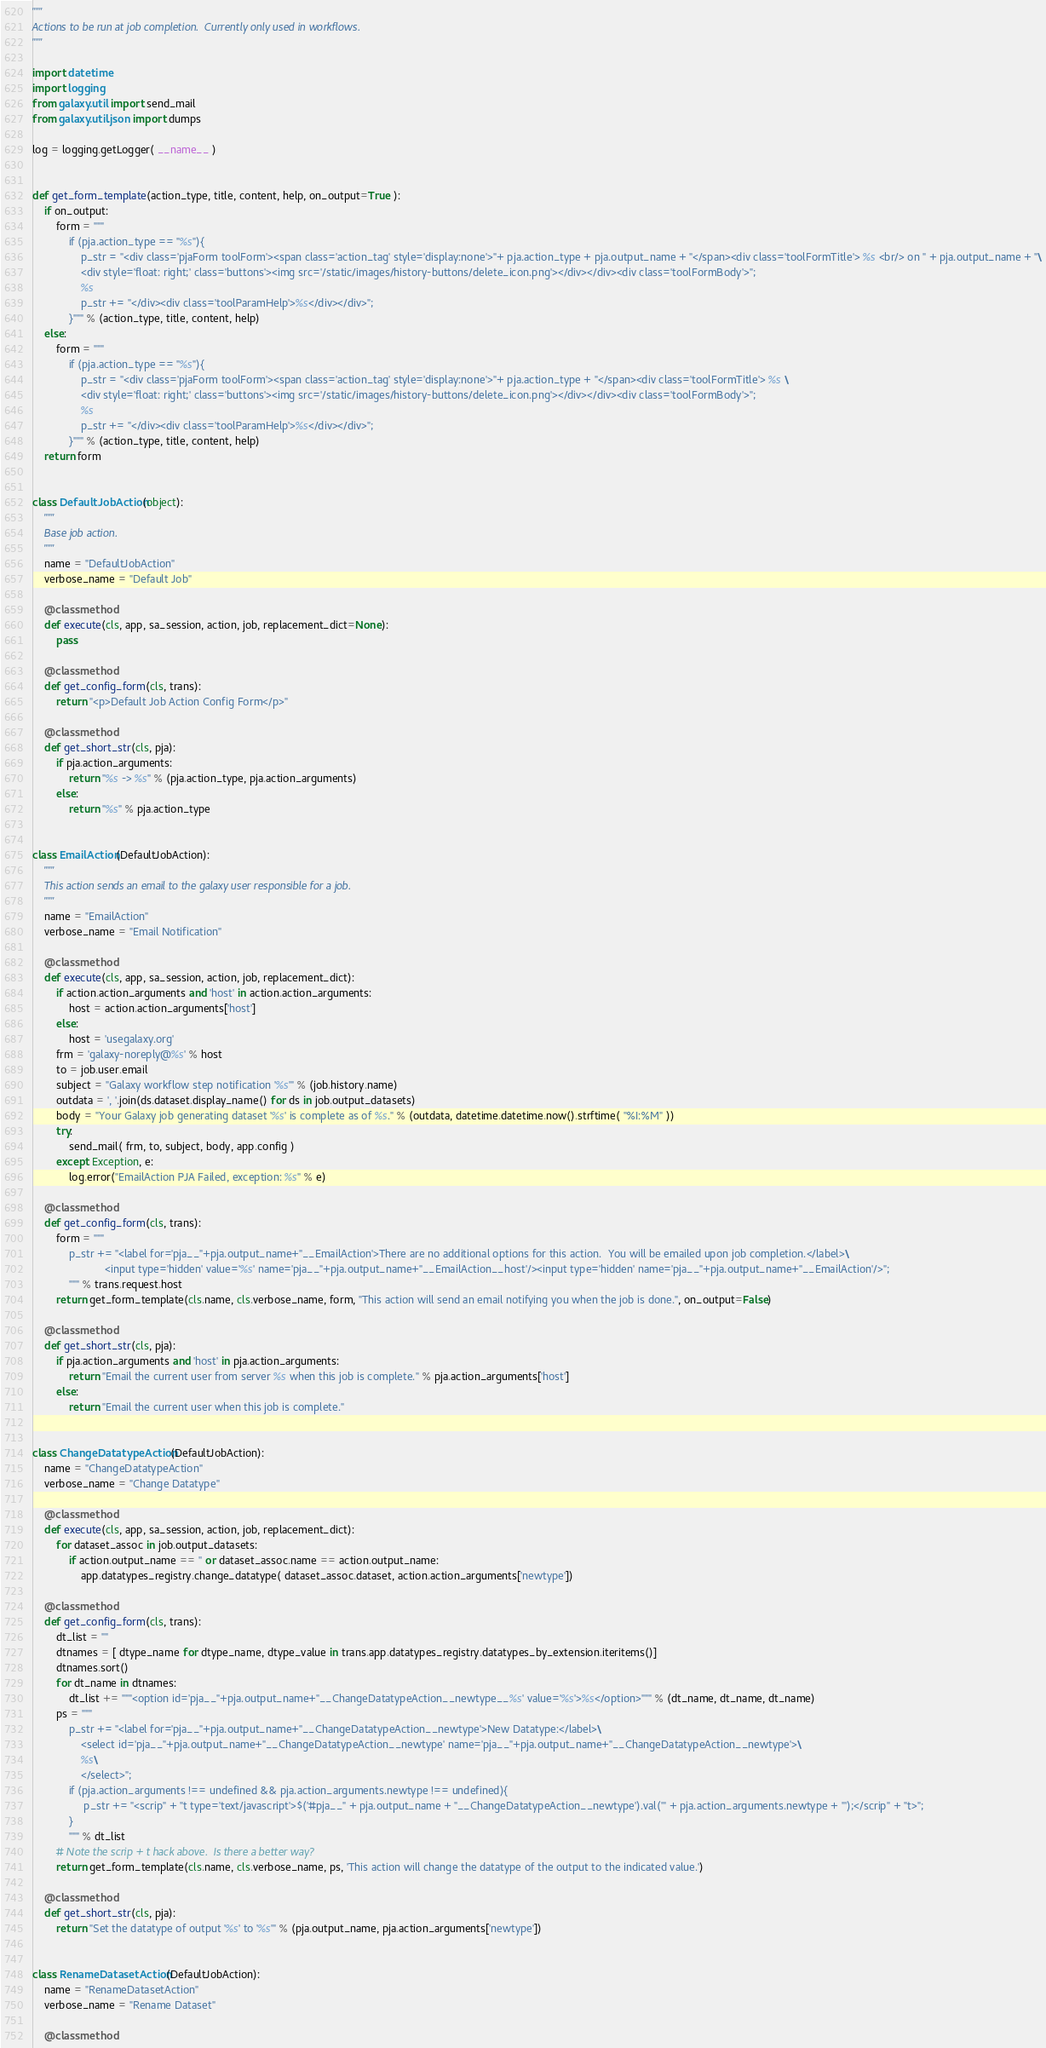Convert code to text. <code><loc_0><loc_0><loc_500><loc_500><_Python_>"""
Actions to be run at job completion.  Currently only used in workflows.
"""

import datetime
import logging
from galaxy.util import send_mail
from galaxy.util.json import dumps

log = logging.getLogger( __name__ )


def get_form_template(action_type, title, content, help, on_output=True ):
    if on_output:
        form = """
            if (pja.action_type == "%s"){
                p_str = "<div class='pjaForm toolForm'><span class='action_tag' style='display:none'>"+ pja.action_type + pja.output_name + "</span><div class='toolFormTitle'> %s <br/> on " + pja.output_name + "\
                <div style='float: right;' class='buttons'><img src='/static/images/history-buttons/delete_icon.png'></div></div><div class='toolFormBody'>";
                %s
                p_str += "</div><div class='toolParamHelp'>%s</div></div>";
            }""" % (action_type, title, content, help)
    else:
        form = """
            if (pja.action_type == "%s"){
                p_str = "<div class='pjaForm toolForm'><span class='action_tag' style='display:none'>"+ pja.action_type + "</span><div class='toolFormTitle'> %s \
                <div style='float: right;' class='buttons'><img src='/static/images/history-buttons/delete_icon.png'></div></div><div class='toolFormBody'>";
                %s
                p_str += "</div><div class='toolParamHelp'>%s</div></div>";
            }""" % (action_type, title, content, help)
    return form


class DefaultJobAction(object):
    """
    Base job action.
    """
    name = "DefaultJobAction"
    verbose_name = "Default Job"

    @classmethod
    def execute(cls, app, sa_session, action, job, replacement_dict=None):
        pass

    @classmethod
    def get_config_form(cls, trans):
        return "<p>Default Job Action Config Form</p>"

    @classmethod
    def get_short_str(cls, pja):
        if pja.action_arguments:
            return "%s -> %s" % (pja.action_type, pja.action_arguments)
        else:
            return "%s" % pja.action_type


class EmailAction(DefaultJobAction):
    """
    This action sends an email to the galaxy user responsible for a job.
    """
    name = "EmailAction"
    verbose_name = "Email Notification"

    @classmethod
    def execute(cls, app, sa_session, action, job, replacement_dict):
        if action.action_arguments and 'host' in action.action_arguments:
            host = action.action_arguments['host']
        else:
            host = 'usegalaxy.org'
        frm = 'galaxy-noreply@%s' % host
        to = job.user.email
        subject = "Galaxy workflow step notification '%s'" % (job.history.name)
        outdata = ', '.join(ds.dataset.display_name() for ds in job.output_datasets)
        body = "Your Galaxy job generating dataset '%s' is complete as of %s." % (outdata, datetime.datetime.now().strftime( "%I:%M" ))
        try:
            send_mail( frm, to, subject, body, app.config )
        except Exception, e:
            log.error("EmailAction PJA Failed, exception: %s" % e)

    @classmethod
    def get_config_form(cls, trans):
        form = """
            p_str += "<label for='pja__"+pja.output_name+"__EmailAction'>There are no additional options for this action.  You will be emailed upon job completion.</label>\
                        <input type='hidden' value='%s' name='pja__"+pja.output_name+"__EmailAction__host'/><input type='hidden' name='pja__"+pja.output_name+"__EmailAction'/>";
            """ % trans.request.host
        return get_form_template(cls.name, cls.verbose_name, form, "This action will send an email notifying you when the job is done.", on_output=False)

    @classmethod
    def get_short_str(cls, pja):
        if pja.action_arguments and 'host' in pja.action_arguments:
            return "Email the current user from server %s when this job is complete." % pja.action_arguments['host']
        else:
            return "Email the current user when this job is complete."


class ChangeDatatypeAction(DefaultJobAction):
    name = "ChangeDatatypeAction"
    verbose_name = "Change Datatype"

    @classmethod
    def execute(cls, app, sa_session, action, job, replacement_dict):
        for dataset_assoc in job.output_datasets:
            if action.output_name == '' or dataset_assoc.name == action.output_name:
                app.datatypes_registry.change_datatype( dataset_assoc.dataset, action.action_arguments['newtype'])

    @classmethod
    def get_config_form(cls, trans):
        dt_list = ""
        dtnames = [ dtype_name for dtype_name, dtype_value in trans.app.datatypes_registry.datatypes_by_extension.iteritems()]
        dtnames.sort()
        for dt_name in dtnames:
            dt_list += """<option id='pja__"+pja.output_name+"__ChangeDatatypeAction__newtype__%s' value='%s'>%s</option>""" % (dt_name, dt_name, dt_name)
        ps = """
            p_str += "<label for='pja__"+pja.output_name+"__ChangeDatatypeAction__newtype'>New Datatype:</label>\
                <select id='pja__"+pja.output_name+"__ChangeDatatypeAction__newtype' name='pja__"+pja.output_name+"__ChangeDatatypeAction__newtype'>\
                %s\
                </select>";
            if (pja.action_arguments !== undefined && pja.action_arguments.newtype !== undefined){
                 p_str += "<scrip" + "t type='text/javascript'>$('#pja__" + pja.output_name + "__ChangeDatatypeAction__newtype').val('" + pja.action_arguments.newtype + "');</scrip" + "t>";
            }
            """ % dt_list
        # Note the scrip + t hack above.  Is there a better way?
        return get_form_template(cls.name, cls.verbose_name, ps, 'This action will change the datatype of the output to the indicated value.')

    @classmethod
    def get_short_str(cls, pja):
        return "Set the datatype of output '%s' to '%s'" % (pja.output_name, pja.action_arguments['newtype'])


class RenameDatasetAction(DefaultJobAction):
    name = "RenameDatasetAction"
    verbose_name = "Rename Dataset"

    @classmethod</code> 